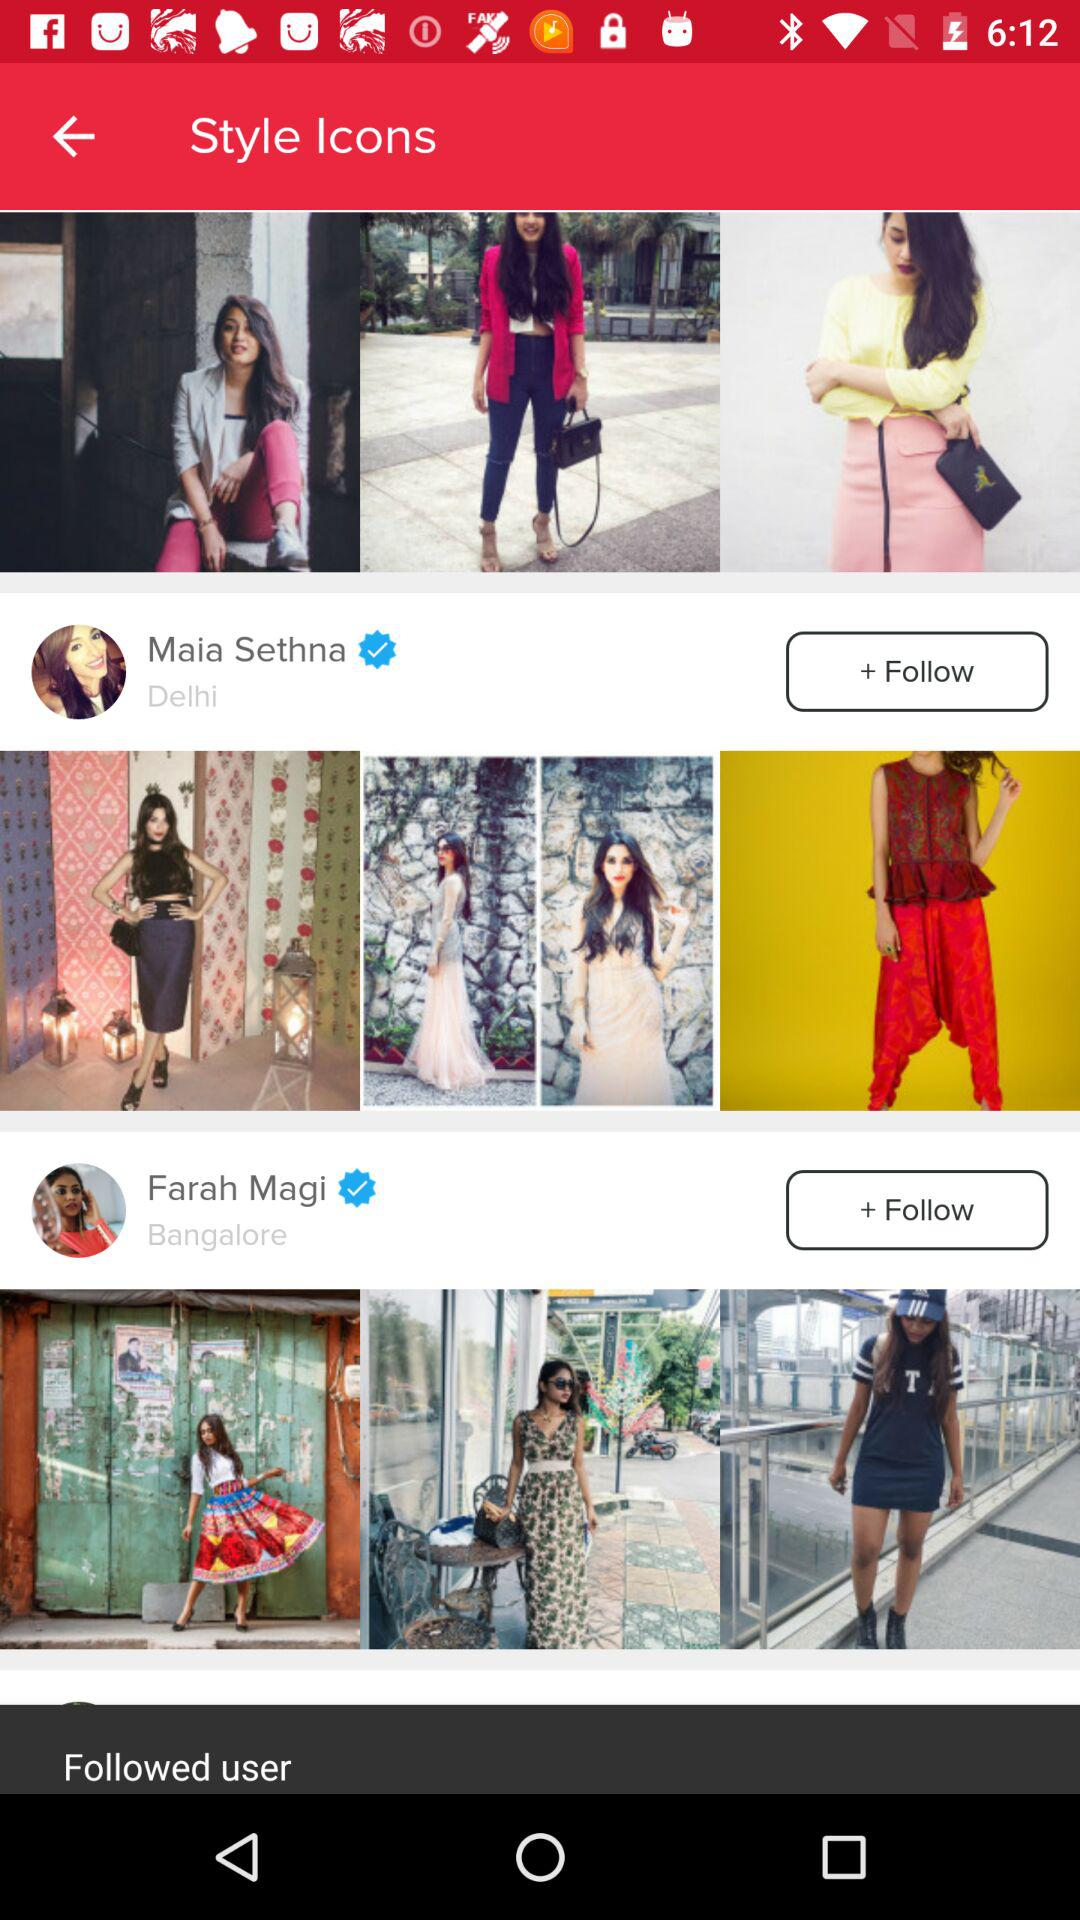What is Maia Sethna's location? Maia Sethna's location is Delhi. 